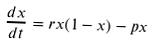Convert formula to latex. <formula><loc_0><loc_0><loc_500><loc_500>\frac { d x } { d t } = r x ( 1 - x ) - p x</formula> 